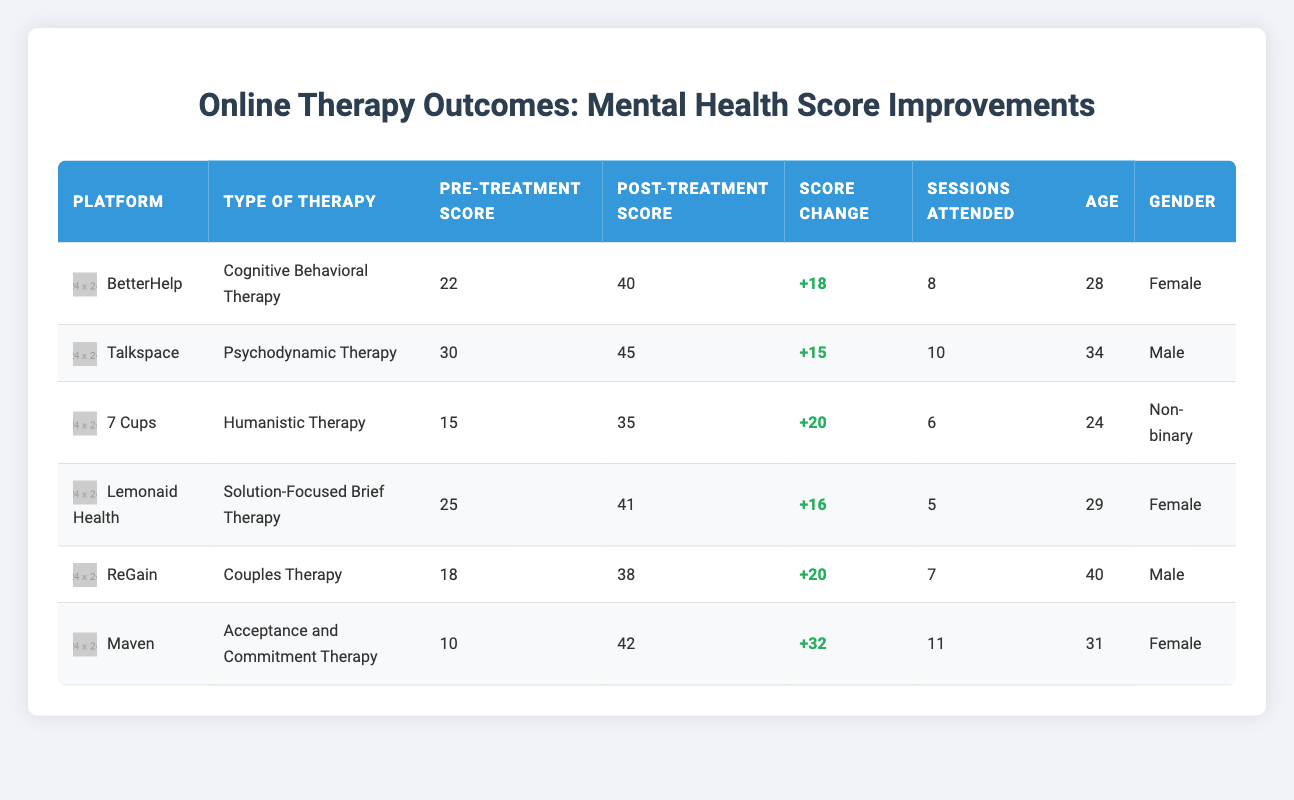What is the highest post-treatment score in the table? The highest post-treatment score can be found by reviewing the post-treatment scores of all clients. The scores are 40, 45, 35, 41, 38, and 42. The maximum value among these is 45.
Answer: 45 Which therapy type had the widest improvement in scores? To find which therapy had the highest score change, I will calculate the score change for each entry: Cognitive Behavioral Therapy (+18), Psychodynamic Therapy (+15), Humanistic Therapy (+20), Solution-Focused Brief Therapy (+16), Couples Therapy (+20), Acceptance and Commitment Therapy (+32). The largest increase is +32 from Acceptance and Commitment Therapy.
Answer: Acceptance and Commitment Therapy Is there a client aged 40 or older receiving therapy? By checking the ages listed in the table (28, 34, 24, 29, 40, 31), I see there is one client aged 40. Therefore, the statement is true.
Answer: Yes What is the average pre-treatment score across all clients? To calculate the average pre-treatment score, I sum the pre-treatment scores: (22 + 30 + 15 + 25 + 18 + 10) = 120. There are 6 clients, so the average score is 120/6 = 20.
Answer: 20 How many sessions, on average, did clients attend for therapy? The total number of sessions attended is (8 + 10 + 6 + 5 + 7 + 11) = 47. Dividing this by the number of clients (6), the average is 47/6 = 7.83.
Answer: 7.83 